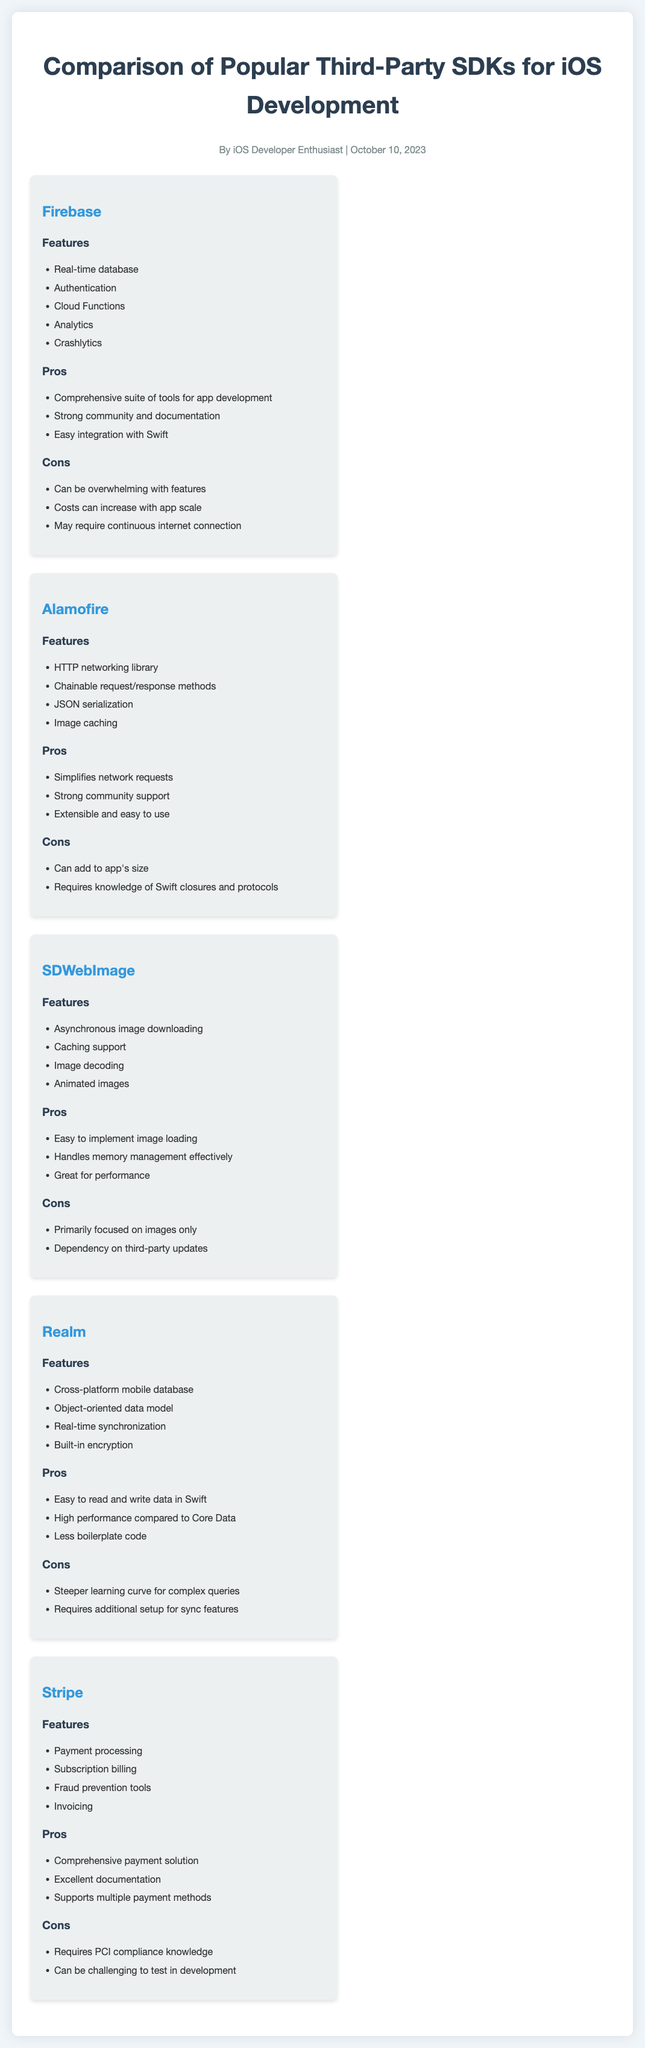What are the features of Firebase? The features of Firebase include real-time database, authentication, cloud functions, analytics, and Crashlytics.
Answer: Real-time database, authentication, cloud functions, analytics, Crashlytics What is one of the pros of Alamofire? A pro of Alamofire is that it simplifies network requests.
Answer: Simplifies network requests What are the cons of SDWebImage? The cons of SDWebImage are that it is primarily focused on images only and has a dependency on third-party updates.
Answer: Primarily focused on images only, dependency on third-party updates How many features are listed for Realm? The document lists four features for Realm: cross-platform mobile database, object-oriented data model, real-time synchronization, and built-in encryption.
Answer: Four features What is the main focus of the Stripe SDK? The main focus of the Stripe SDK is payment processing.
Answer: Payment processing What is a significant pro of using Firebase? A significant pro of using Firebase is its comprehensive suite of tools for app development.
Answer: Comprehensive suite of tools for app development Which library simplifies image loading? SDWebImage simplifies image loading.
Answer: SDWebImage What is one of the cons of using Stripe? One of the cons of using Stripe is that it requires PCI compliance knowledge.
Answer: Requires PCI compliance knowledge Which third-party SDK has a strong community and documentation? Firebase has a strong community and documentation.
Answer: Firebase 